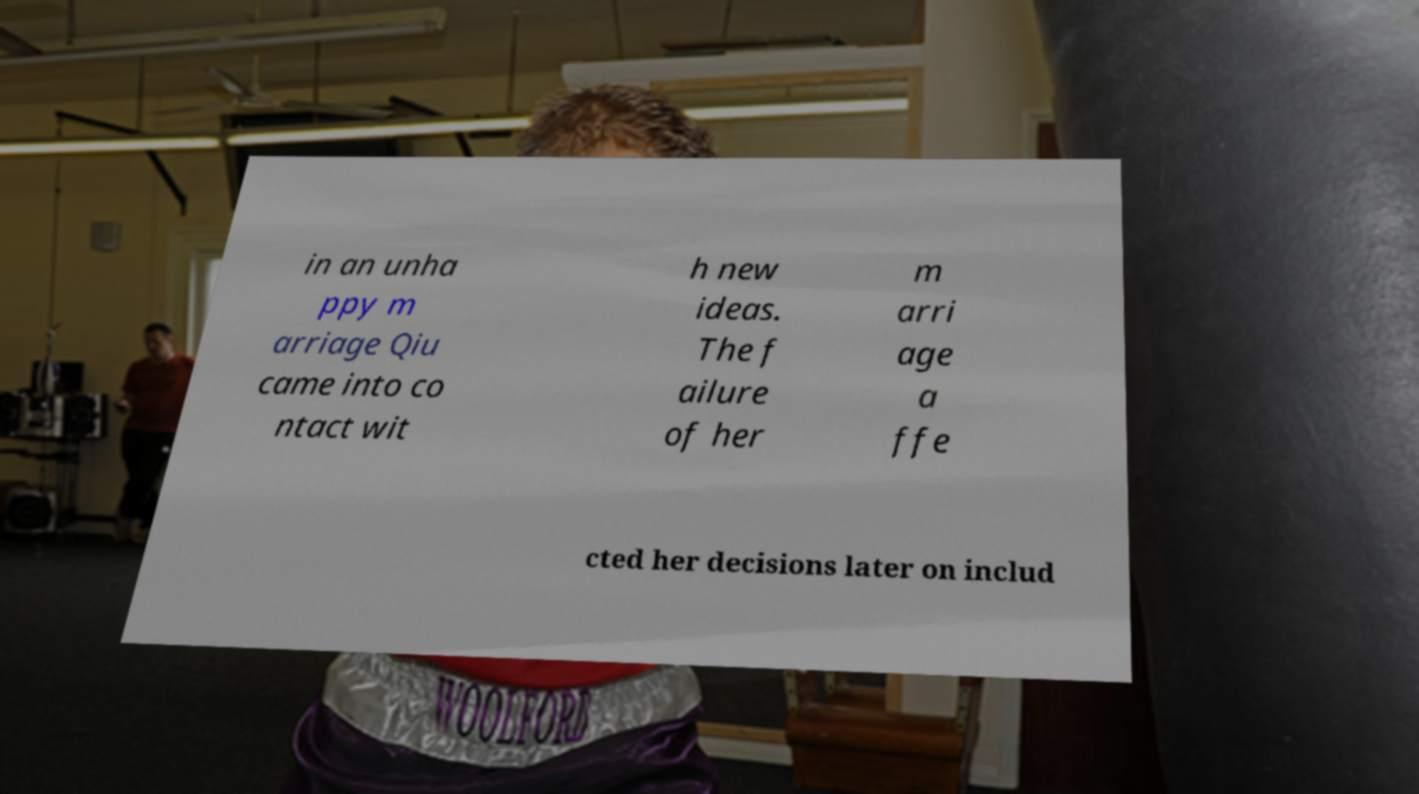Could you extract and type out the text from this image? in an unha ppy m arriage Qiu came into co ntact wit h new ideas. The f ailure of her m arri age a ffe cted her decisions later on includ 